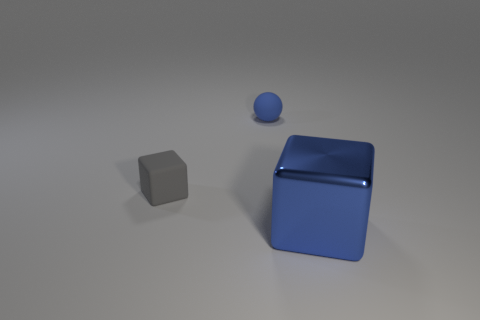How many other things are there of the same material as the blue block? After reviewing the image, it appears that there is one other object of a similar material, which is the small blue sphere. Although the two objects share a similar hue and reflective quality, suggesting they may be made of a like material, without more context it's not possible to confirm if they are identical in material composition. So, the most accurate answer considering visible clues would be one object seems to share the material characteristics with the blue block. 